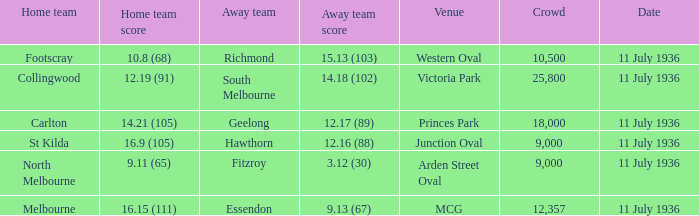When was the game with richmond as Away team? 11 July 1936. 